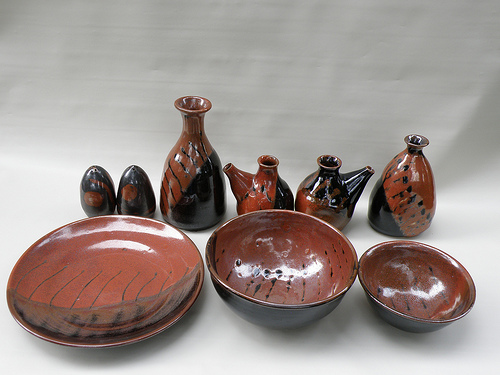Describe the texture and possible tactile experience of these pottery items. The texture of these pottery items is likely to be smooth and polished, with occasional rough areas where the glaze is applied thicker or thinner. The tactile experience includes a cool, solid feel typical of ceramic materials, with the glossy finish providing a slick, almost glass-like surface in contrast to the matte sections. If these pottery items could tell a story, what would it be? If these pottery items could tell a story, they would narrate the journey of their creation, from the meticulous shaping of the clay to the intense heat of the kiln. They would speak of the hands that molded them, the skillful brush strokes that painted their glazes, and the tradition and history they embody. Each piece would share its transformation from a simple lump of earth to a work of art, designed to bring beauty and functionality into people's lives. Imagine these pottery items in an ancient market. What kind of interactions would happen around them? In an ancient market, these pottery items would be at the center of lively interactions. Traders would passionately describe their craftsmanship and utility, while buyers would examine the glaze's sheen and test the pots' sturdiness. Children might marvel at the shiny surfaces, and potters could engage in friendly rivalry, each boasting about the uniqueness of their ware. These items would not just be merchandise but symbols of cultural heritage, economy, and community life. Let's create a vivid scene where these pottery items are part of a grand feast. What does it look like? In the grand hall, tables draped with rich fabrics, these pottery items take center stage. The large bowls are filled with sumptuous stews and fresh salads, their vibrant colors complementing the food. Plates hold assortments of breads and cheeses, while vases filled with wildflowers add a touch of natural elegance. Soft candlelight reflects off their glossy surfaces, creating a warm and inviting atmosphere. Guests marvel at the pottery's beauty as they share stories and laughter, finding joy in both the feast and the artistry of the vessels. 